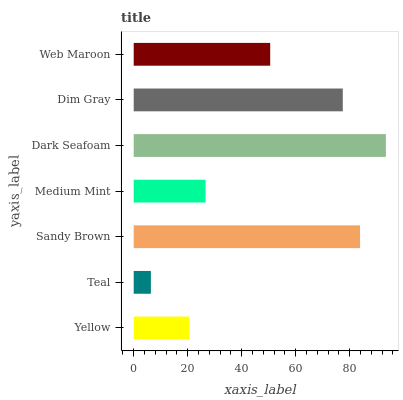Is Teal the minimum?
Answer yes or no. Yes. Is Dark Seafoam the maximum?
Answer yes or no. Yes. Is Sandy Brown the minimum?
Answer yes or no. No. Is Sandy Brown the maximum?
Answer yes or no. No. Is Sandy Brown greater than Teal?
Answer yes or no. Yes. Is Teal less than Sandy Brown?
Answer yes or no. Yes. Is Teal greater than Sandy Brown?
Answer yes or no. No. Is Sandy Brown less than Teal?
Answer yes or no. No. Is Web Maroon the high median?
Answer yes or no. Yes. Is Web Maroon the low median?
Answer yes or no. Yes. Is Medium Mint the high median?
Answer yes or no. No. Is Sandy Brown the low median?
Answer yes or no. No. 